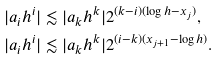Convert formula to latex. <formula><loc_0><loc_0><loc_500><loc_500>| a _ { i } h ^ { i } | & \lesssim | a _ { k } h ^ { k } | 2 ^ { ( k - i ) ( \log h - x _ { j } ) } , \\ | a _ { i } h ^ { i } | & \lesssim | a _ { k } h ^ { k } | 2 ^ { ( i - k ) ( x _ { j + 1 } - \log h ) } .</formula> 